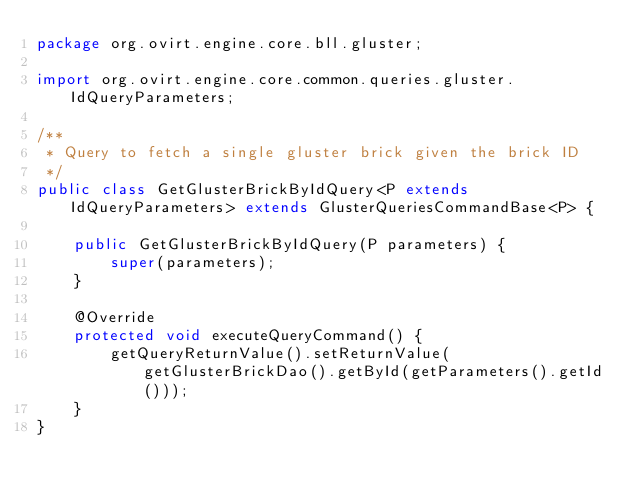<code> <loc_0><loc_0><loc_500><loc_500><_Java_>package org.ovirt.engine.core.bll.gluster;

import org.ovirt.engine.core.common.queries.gluster.IdQueryParameters;

/**
 * Query to fetch a single gluster brick given the brick ID
 */
public class GetGlusterBrickByIdQuery<P extends IdQueryParameters> extends GlusterQueriesCommandBase<P> {

    public GetGlusterBrickByIdQuery(P parameters) {
        super(parameters);
    }

    @Override
    protected void executeQueryCommand() {
        getQueryReturnValue().setReturnValue(getGlusterBrickDao().getById(getParameters().getId()));
    }
}
</code> 